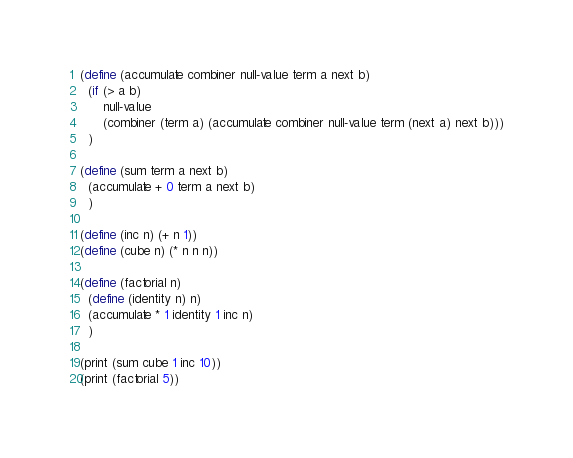<code> <loc_0><loc_0><loc_500><loc_500><_Scheme_>(define (accumulate combiner null-value term a next b)
  (if (> a b)
      null-value
      (combiner (term a) (accumulate combiner null-value term (next a) next b)))
  )

(define (sum term a next b)
  (accumulate + 0 term a next b)
  )

(define (inc n) (+ n 1))
(define (cube n) (* n n n))

(define (factorial n)
  (define (identity n) n)
  (accumulate * 1 identity 1 inc n)
  )

(print (sum cube 1 inc 10))
(print (factorial 5))
</code> 